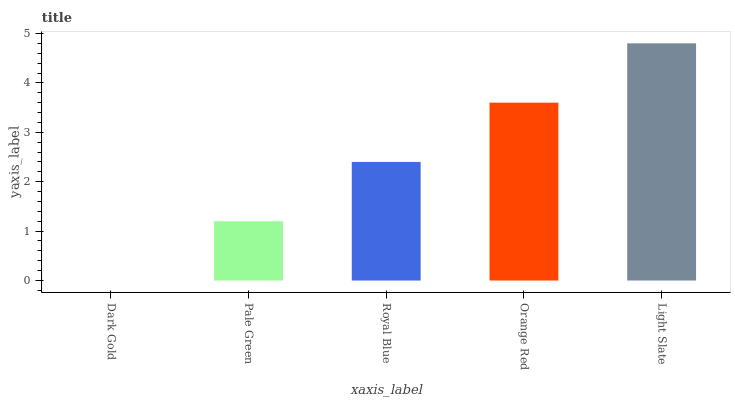Is Dark Gold the minimum?
Answer yes or no. Yes. Is Light Slate the maximum?
Answer yes or no. Yes. Is Pale Green the minimum?
Answer yes or no. No. Is Pale Green the maximum?
Answer yes or no. No. Is Pale Green greater than Dark Gold?
Answer yes or no. Yes. Is Dark Gold less than Pale Green?
Answer yes or no. Yes. Is Dark Gold greater than Pale Green?
Answer yes or no. No. Is Pale Green less than Dark Gold?
Answer yes or no. No. Is Royal Blue the high median?
Answer yes or no. Yes. Is Royal Blue the low median?
Answer yes or no. Yes. Is Light Slate the high median?
Answer yes or no. No. Is Dark Gold the low median?
Answer yes or no. No. 